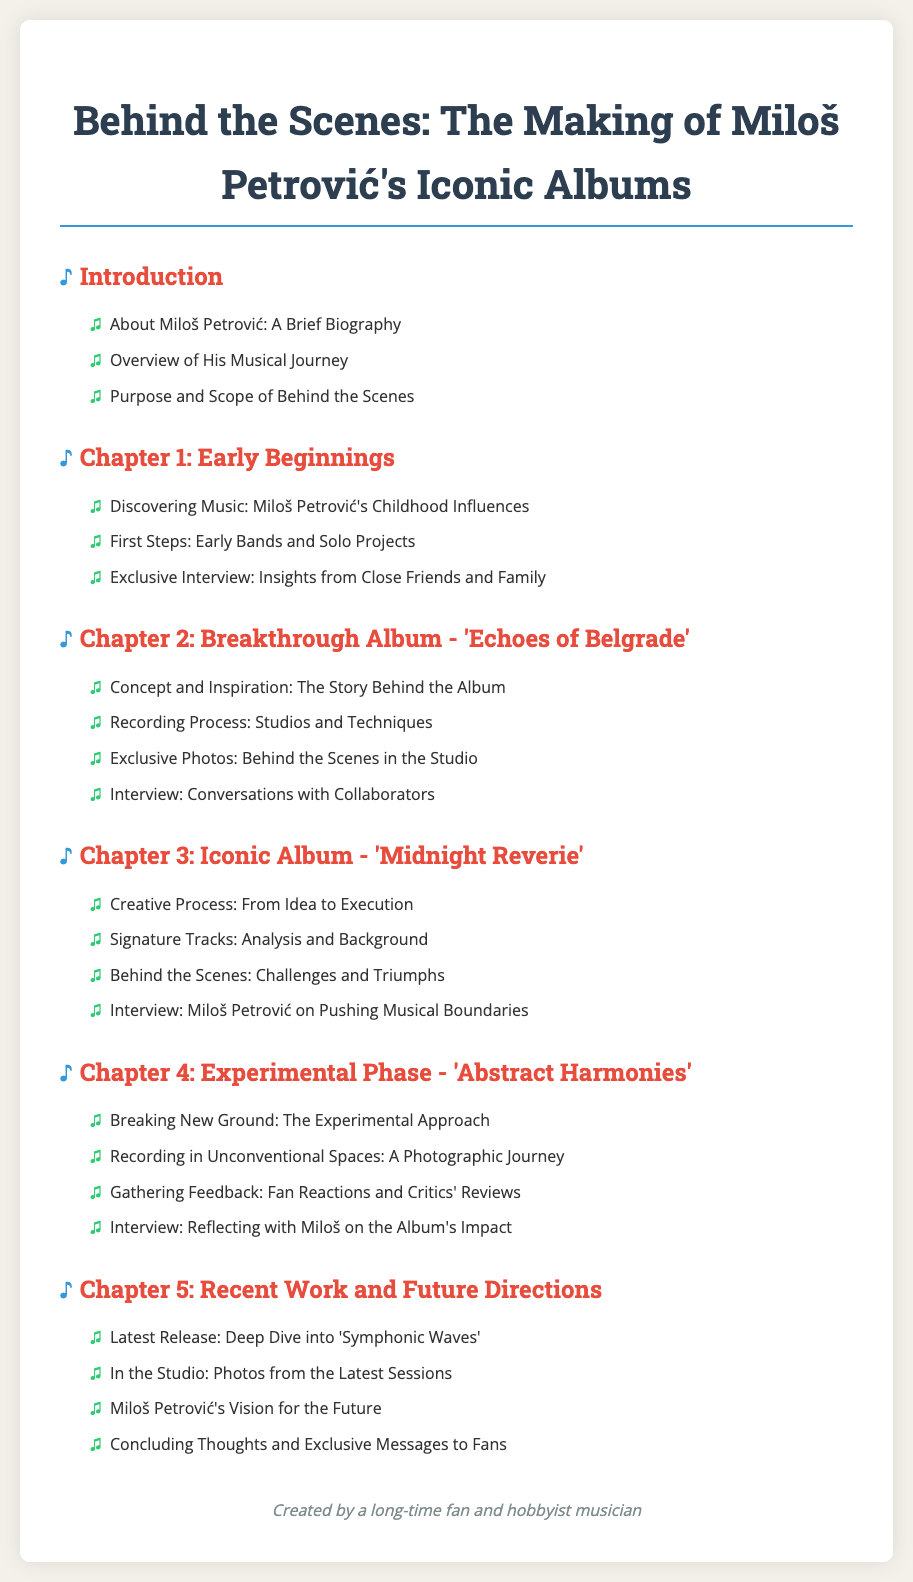What is the title of Miloš Petrović’s iconic albums document? The title of the document is prominently displayed at the top of the page.
Answer: Behind the Scenes: The Making of Miloš Petrović's Iconic Albums How many chapters are in the document? The document lists a total of five chapters in the table of contents.
Answer: 5 What is the focus of Chapter 2? Chapter 2 specifically highlights the breakthrough album, which is mentioned in the chapter title.
Answer: Breakthrough Album - 'Echoes of Belgrade' Which chapter discusses Miloš Petrović's recent work? The title of Chapter 5 indicates it covers Miloš's latest projects and future plans.
Answer: Chapter 5: Recent Work and Future Directions What type of content is included in Chapter 4? The subpoints of Chapter 4 reveal the experimental nature of the album discussed within it.
Answer: Experimental Phase - 'Abstract Harmonies' Who is featured in the exclusive interview of Chapter 3? The title of the interview section in Chapter 3 indicates the subject of the conversation.
Answer: Miloš Petrović What does the document include apart from interviews? The table of contents mentions several types of content beyond interviews, including photos and analysis.
Answer: Exclusive Photos and Analysis What visual style is used for headings in the document? The design includes specific colors and font styles for chapter headings as described in the style rules.
Answer: Serif font with distinct colors and styling 